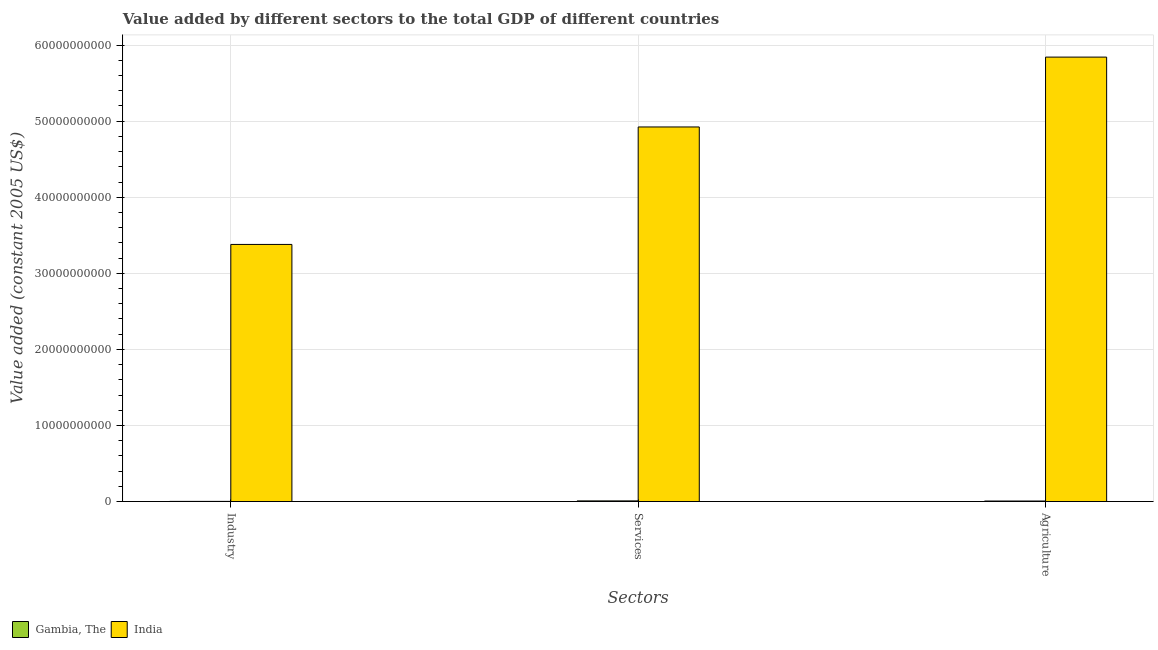What is the label of the 2nd group of bars from the left?
Give a very brief answer. Services. What is the value added by services in Gambia, The?
Your answer should be very brief. 8.78e+07. Across all countries, what is the maximum value added by agricultural sector?
Offer a terse response. 5.84e+1. Across all countries, what is the minimum value added by industrial sector?
Your answer should be very brief. 2.27e+07. In which country was the value added by industrial sector maximum?
Give a very brief answer. India. In which country was the value added by agricultural sector minimum?
Keep it short and to the point. Gambia, The. What is the total value added by services in the graph?
Offer a very short reply. 4.93e+1. What is the difference between the value added by agricultural sector in India and that in Gambia, The?
Offer a very short reply. 5.83e+1. What is the difference between the value added by agricultural sector in Gambia, The and the value added by industrial sector in India?
Provide a short and direct response. -3.37e+1. What is the average value added by agricultural sector per country?
Your response must be concise. 2.92e+1. What is the difference between the value added by agricultural sector and value added by services in Gambia, The?
Ensure brevity in your answer.  -1.66e+07. What is the ratio of the value added by industrial sector in Gambia, The to that in India?
Your answer should be very brief. 0. Is the value added by agricultural sector in Gambia, The less than that in India?
Ensure brevity in your answer.  Yes. Is the difference between the value added by services in India and Gambia, The greater than the difference between the value added by industrial sector in India and Gambia, The?
Ensure brevity in your answer.  Yes. What is the difference between the highest and the second highest value added by agricultural sector?
Your answer should be compact. 5.83e+1. What is the difference between the highest and the lowest value added by agricultural sector?
Your response must be concise. 5.83e+1. Is the sum of the value added by industrial sector in Gambia, The and India greater than the maximum value added by agricultural sector across all countries?
Provide a short and direct response. No. What does the 1st bar from the left in Agriculture represents?
Ensure brevity in your answer.  Gambia, The. Is it the case that in every country, the sum of the value added by industrial sector and value added by services is greater than the value added by agricultural sector?
Your answer should be very brief. Yes. How many bars are there?
Keep it short and to the point. 6. Are all the bars in the graph horizontal?
Give a very brief answer. No. Does the graph contain any zero values?
Provide a short and direct response. No. Does the graph contain grids?
Make the answer very short. Yes. Where does the legend appear in the graph?
Ensure brevity in your answer.  Bottom left. What is the title of the graph?
Offer a terse response. Value added by different sectors to the total GDP of different countries. What is the label or title of the X-axis?
Your answer should be compact. Sectors. What is the label or title of the Y-axis?
Provide a succinct answer. Value added (constant 2005 US$). What is the Value added (constant 2005 US$) of Gambia, The in Industry?
Ensure brevity in your answer.  2.27e+07. What is the Value added (constant 2005 US$) of India in Industry?
Provide a succinct answer. 3.38e+1. What is the Value added (constant 2005 US$) of Gambia, The in Services?
Provide a succinct answer. 8.78e+07. What is the Value added (constant 2005 US$) in India in Services?
Offer a terse response. 4.92e+1. What is the Value added (constant 2005 US$) in Gambia, The in Agriculture?
Provide a short and direct response. 7.12e+07. What is the Value added (constant 2005 US$) in India in Agriculture?
Your answer should be very brief. 5.84e+1. Across all Sectors, what is the maximum Value added (constant 2005 US$) of Gambia, The?
Ensure brevity in your answer.  8.78e+07. Across all Sectors, what is the maximum Value added (constant 2005 US$) in India?
Give a very brief answer. 5.84e+1. Across all Sectors, what is the minimum Value added (constant 2005 US$) of Gambia, The?
Give a very brief answer. 2.27e+07. Across all Sectors, what is the minimum Value added (constant 2005 US$) in India?
Keep it short and to the point. 3.38e+1. What is the total Value added (constant 2005 US$) of Gambia, The in the graph?
Ensure brevity in your answer.  1.82e+08. What is the total Value added (constant 2005 US$) in India in the graph?
Make the answer very short. 1.41e+11. What is the difference between the Value added (constant 2005 US$) of Gambia, The in Industry and that in Services?
Keep it short and to the point. -6.51e+07. What is the difference between the Value added (constant 2005 US$) of India in Industry and that in Services?
Provide a short and direct response. -1.54e+1. What is the difference between the Value added (constant 2005 US$) in Gambia, The in Industry and that in Agriculture?
Provide a succinct answer. -4.84e+07. What is the difference between the Value added (constant 2005 US$) in India in Industry and that in Agriculture?
Your response must be concise. -2.46e+1. What is the difference between the Value added (constant 2005 US$) in Gambia, The in Services and that in Agriculture?
Your response must be concise. 1.66e+07. What is the difference between the Value added (constant 2005 US$) in India in Services and that in Agriculture?
Your answer should be very brief. -9.18e+09. What is the difference between the Value added (constant 2005 US$) in Gambia, The in Industry and the Value added (constant 2005 US$) in India in Services?
Make the answer very short. -4.92e+1. What is the difference between the Value added (constant 2005 US$) of Gambia, The in Industry and the Value added (constant 2005 US$) of India in Agriculture?
Offer a terse response. -5.84e+1. What is the difference between the Value added (constant 2005 US$) in Gambia, The in Services and the Value added (constant 2005 US$) in India in Agriculture?
Ensure brevity in your answer.  -5.83e+1. What is the average Value added (constant 2005 US$) in Gambia, The per Sectors?
Provide a short and direct response. 6.06e+07. What is the average Value added (constant 2005 US$) of India per Sectors?
Your answer should be compact. 4.72e+1. What is the difference between the Value added (constant 2005 US$) in Gambia, The and Value added (constant 2005 US$) in India in Industry?
Your response must be concise. -3.38e+1. What is the difference between the Value added (constant 2005 US$) of Gambia, The and Value added (constant 2005 US$) of India in Services?
Ensure brevity in your answer.  -4.91e+1. What is the difference between the Value added (constant 2005 US$) of Gambia, The and Value added (constant 2005 US$) of India in Agriculture?
Your response must be concise. -5.83e+1. What is the ratio of the Value added (constant 2005 US$) in Gambia, The in Industry to that in Services?
Make the answer very short. 0.26. What is the ratio of the Value added (constant 2005 US$) in India in Industry to that in Services?
Make the answer very short. 0.69. What is the ratio of the Value added (constant 2005 US$) in Gambia, The in Industry to that in Agriculture?
Give a very brief answer. 0.32. What is the ratio of the Value added (constant 2005 US$) in India in Industry to that in Agriculture?
Offer a terse response. 0.58. What is the ratio of the Value added (constant 2005 US$) in Gambia, The in Services to that in Agriculture?
Your answer should be compact. 1.23. What is the ratio of the Value added (constant 2005 US$) of India in Services to that in Agriculture?
Your answer should be very brief. 0.84. What is the difference between the highest and the second highest Value added (constant 2005 US$) in Gambia, The?
Keep it short and to the point. 1.66e+07. What is the difference between the highest and the second highest Value added (constant 2005 US$) in India?
Keep it short and to the point. 9.18e+09. What is the difference between the highest and the lowest Value added (constant 2005 US$) in Gambia, The?
Offer a very short reply. 6.51e+07. What is the difference between the highest and the lowest Value added (constant 2005 US$) of India?
Make the answer very short. 2.46e+1. 